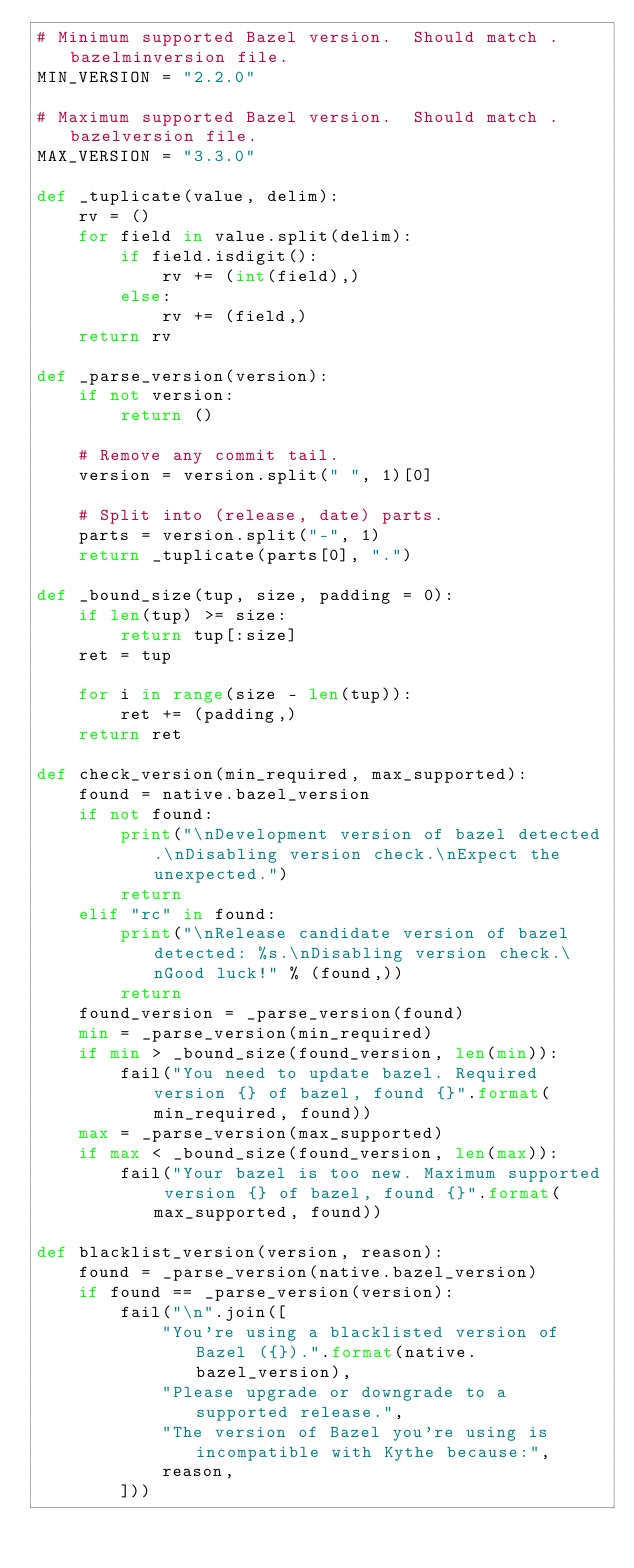<code> <loc_0><loc_0><loc_500><loc_500><_Python_># Minimum supported Bazel version.  Should match .bazelminversion file.
MIN_VERSION = "2.2.0"

# Maximum supported Bazel version.  Should match .bazelversion file.
MAX_VERSION = "3.3.0"

def _tuplicate(value, delim):
    rv = ()
    for field in value.split(delim):
        if field.isdigit():
            rv += (int(field),)
        else:
            rv += (field,)
    return rv

def _parse_version(version):
    if not version:
        return ()

    # Remove any commit tail.
    version = version.split(" ", 1)[0]

    # Split into (release, date) parts.
    parts = version.split("-", 1)
    return _tuplicate(parts[0], ".")

def _bound_size(tup, size, padding = 0):
    if len(tup) >= size:
        return tup[:size]
    ret = tup

    for i in range(size - len(tup)):
        ret += (padding,)
    return ret

def check_version(min_required, max_supported):
    found = native.bazel_version
    if not found:
        print("\nDevelopment version of bazel detected.\nDisabling version check.\nExpect the unexpected.")
        return
    elif "rc" in found:
        print("\nRelease candidate version of bazel detected: %s.\nDisabling version check.\nGood luck!" % (found,))
        return
    found_version = _parse_version(found)
    min = _parse_version(min_required)
    if min > _bound_size(found_version, len(min)):
        fail("You need to update bazel. Required version {} of bazel, found {}".format(min_required, found))
    max = _parse_version(max_supported)
    if max < _bound_size(found_version, len(max)):
        fail("Your bazel is too new. Maximum supported version {} of bazel, found {}".format(max_supported, found))

def blacklist_version(version, reason):
    found = _parse_version(native.bazel_version)
    if found == _parse_version(version):
        fail("\n".join([
            "You're using a blacklisted version of Bazel ({}).".format(native.bazel_version),
            "Please upgrade or downgrade to a supported release.",
            "The version of Bazel you're using is incompatible with Kythe because:",
            reason,
        ]))
</code> 